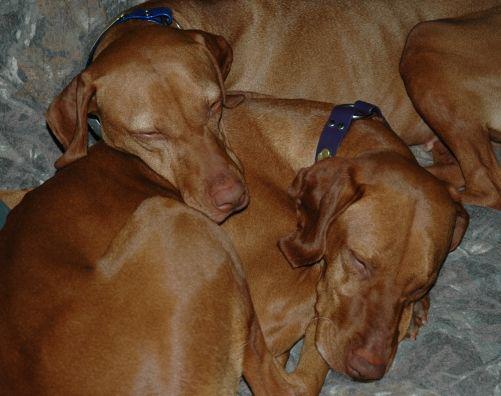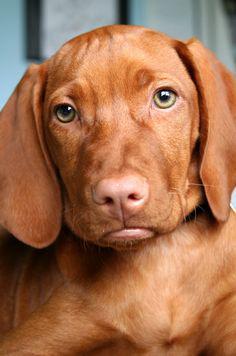The first image is the image on the left, the second image is the image on the right. Assess this claim about the two images: "One dog faces straight ahead, at least one dog is wearing a blue collar, and at least two dogs are wearing collars.". Correct or not? Answer yes or no. Yes. The first image is the image on the left, the second image is the image on the right. Evaluate the accuracy of this statement regarding the images: "There are exactly two dogs.". Is it true? Answer yes or no. No. 